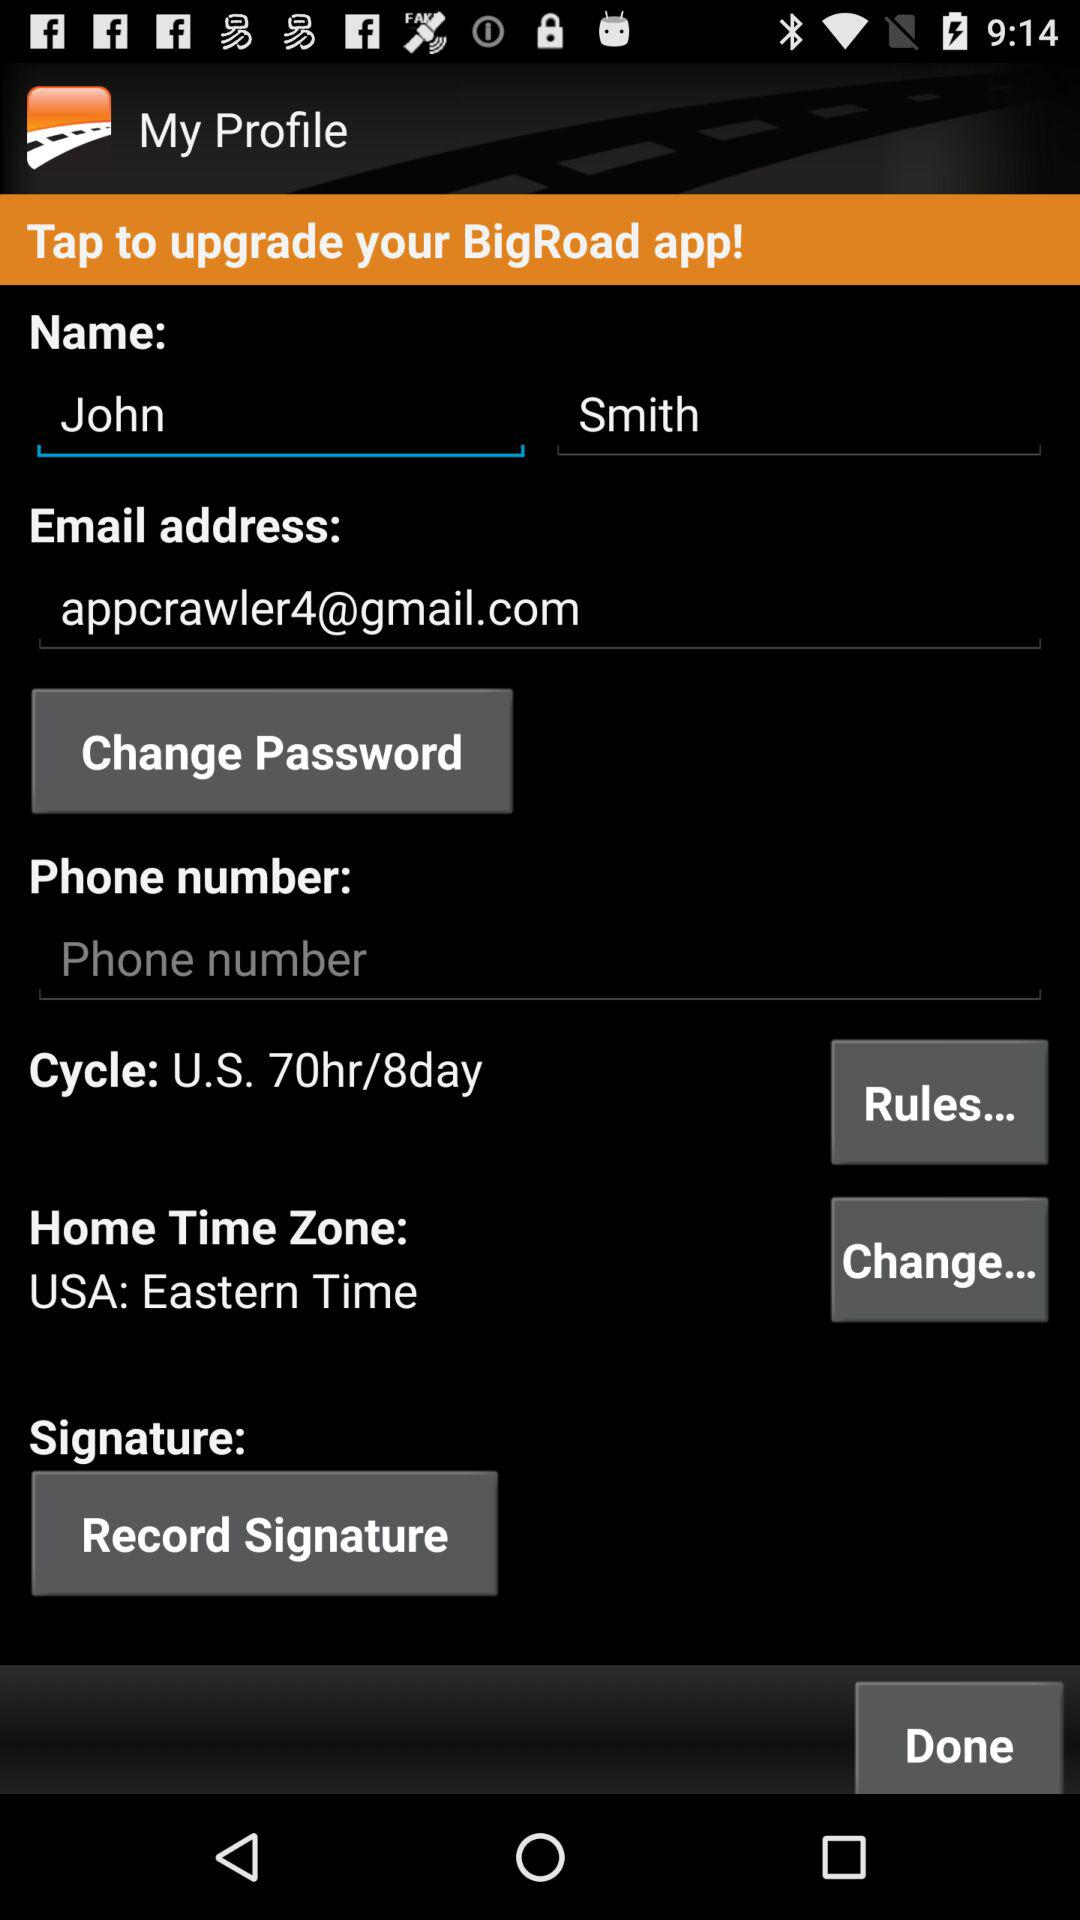What's the "Home Time Zone"? The "Home Time Zone" is "USA: Eastern Time". 